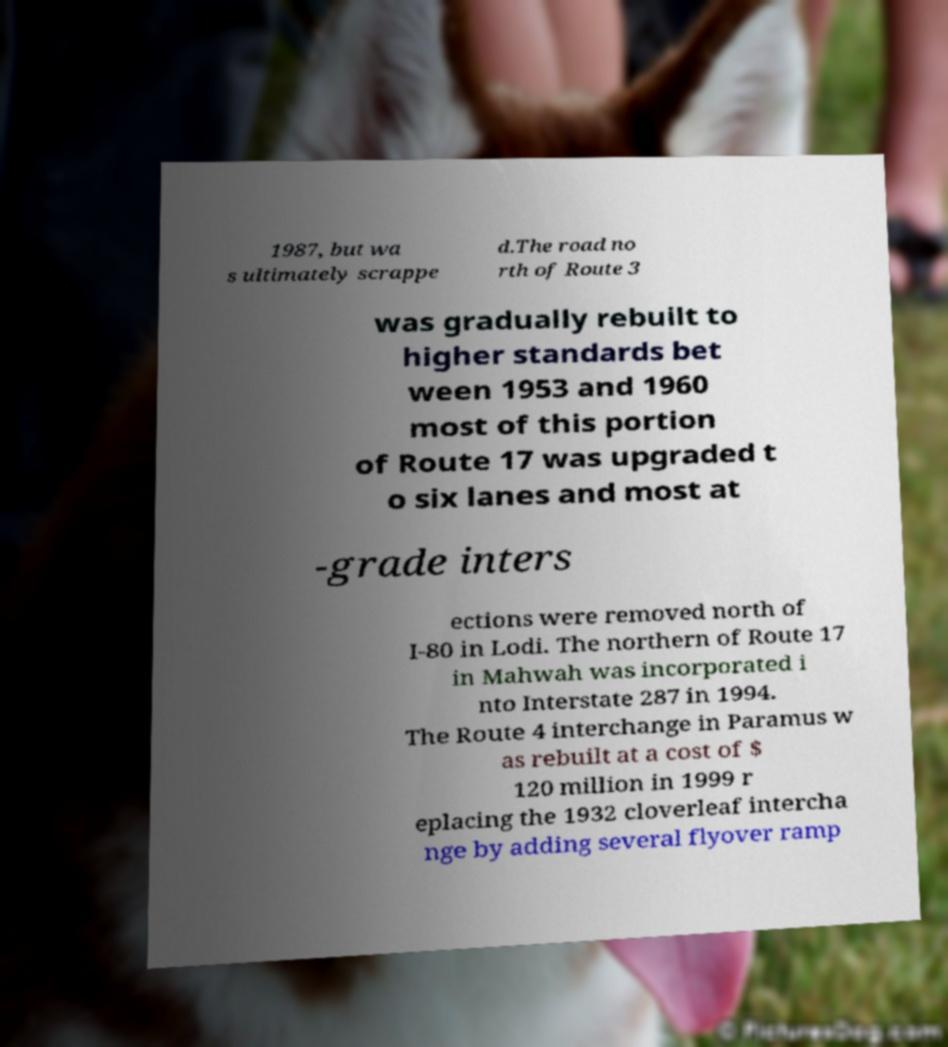Please read and relay the text visible in this image. What does it say? 1987, but wa s ultimately scrappe d.The road no rth of Route 3 was gradually rebuilt to higher standards bet ween 1953 and 1960 most of this portion of Route 17 was upgraded t o six lanes and most at -grade inters ections were removed north of I-80 in Lodi. The northern of Route 17 in Mahwah was incorporated i nto Interstate 287 in 1994. The Route 4 interchange in Paramus w as rebuilt at a cost of $ 120 million in 1999 r eplacing the 1932 cloverleaf intercha nge by adding several flyover ramp 